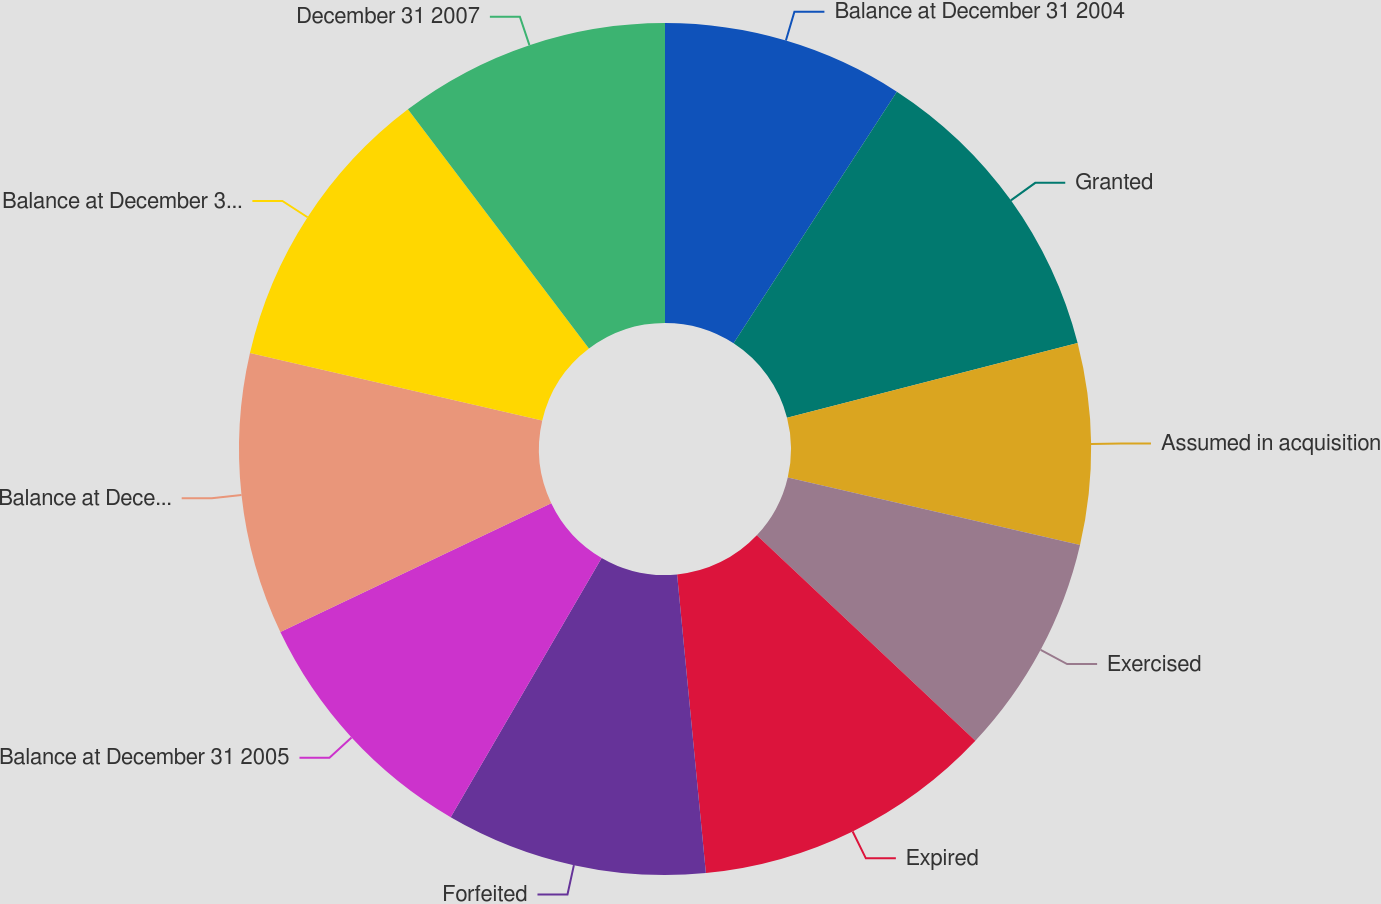<chart> <loc_0><loc_0><loc_500><loc_500><pie_chart><fcel>Balance at December 31 2004<fcel>Granted<fcel>Assumed in acquisition<fcel>Exercised<fcel>Expired<fcel>Forfeited<fcel>Balance at December 31 2005<fcel>Balance at December 31 2006<fcel>Balance at December 31 2007<fcel>December 31 2007<nl><fcel>9.16%<fcel>11.84%<fcel>7.62%<fcel>8.39%<fcel>11.46%<fcel>9.92%<fcel>9.54%<fcel>10.69%<fcel>11.07%<fcel>10.31%<nl></chart> 